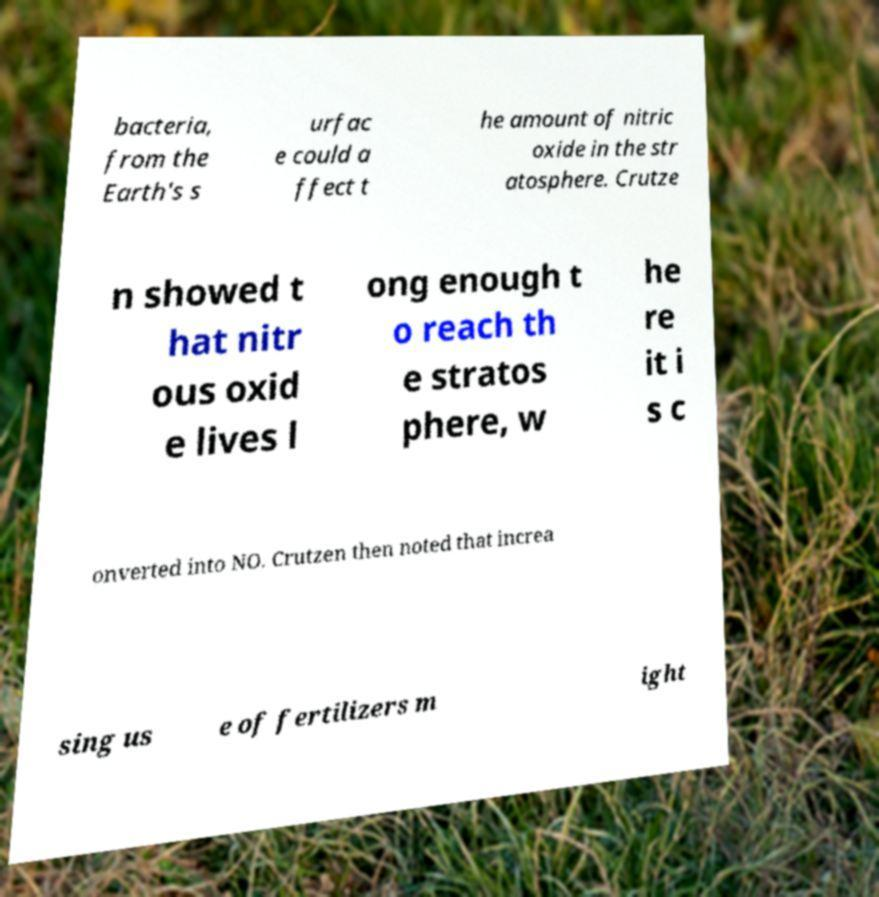Can you accurately transcribe the text from the provided image for me? bacteria, from the Earth's s urfac e could a ffect t he amount of nitric oxide in the str atosphere. Crutze n showed t hat nitr ous oxid e lives l ong enough t o reach th e stratos phere, w he re it i s c onverted into NO. Crutzen then noted that increa sing us e of fertilizers m ight 